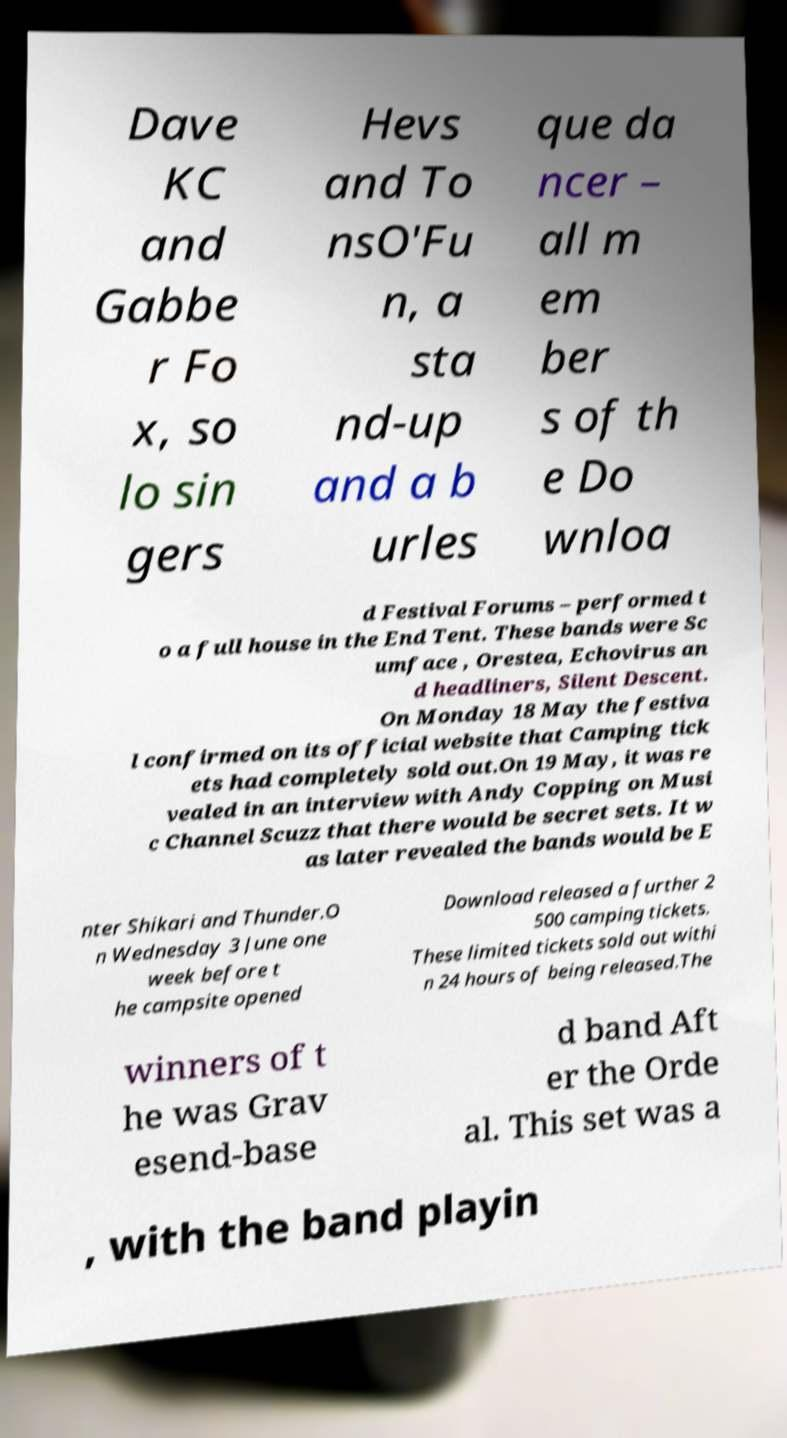There's text embedded in this image that I need extracted. Can you transcribe it verbatim? Dave KC and Gabbe r Fo x, so lo sin gers Hevs and To nsO'Fu n, a sta nd-up and a b urles que da ncer – all m em ber s of th e Do wnloa d Festival Forums – performed t o a full house in the End Tent. These bands were Sc umface , Orestea, Echovirus an d headliners, Silent Descent. On Monday 18 May the festiva l confirmed on its official website that Camping tick ets had completely sold out.On 19 May, it was re vealed in an interview with Andy Copping on Musi c Channel Scuzz that there would be secret sets. It w as later revealed the bands would be E nter Shikari and Thunder.O n Wednesday 3 June one week before t he campsite opened Download released a further 2 500 camping tickets. These limited tickets sold out withi n 24 hours of being released.The winners of t he was Grav esend-base d band Aft er the Orde al. This set was a , with the band playin 